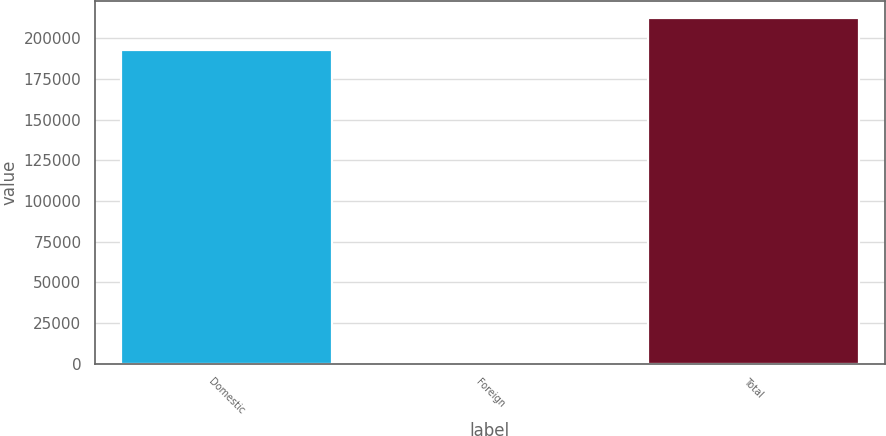Convert chart to OTSL. <chart><loc_0><loc_0><loc_500><loc_500><bar_chart><fcel>Domestic<fcel>Foreign<fcel>Total<nl><fcel>193048<fcel>368<fcel>212353<nl></chart> 